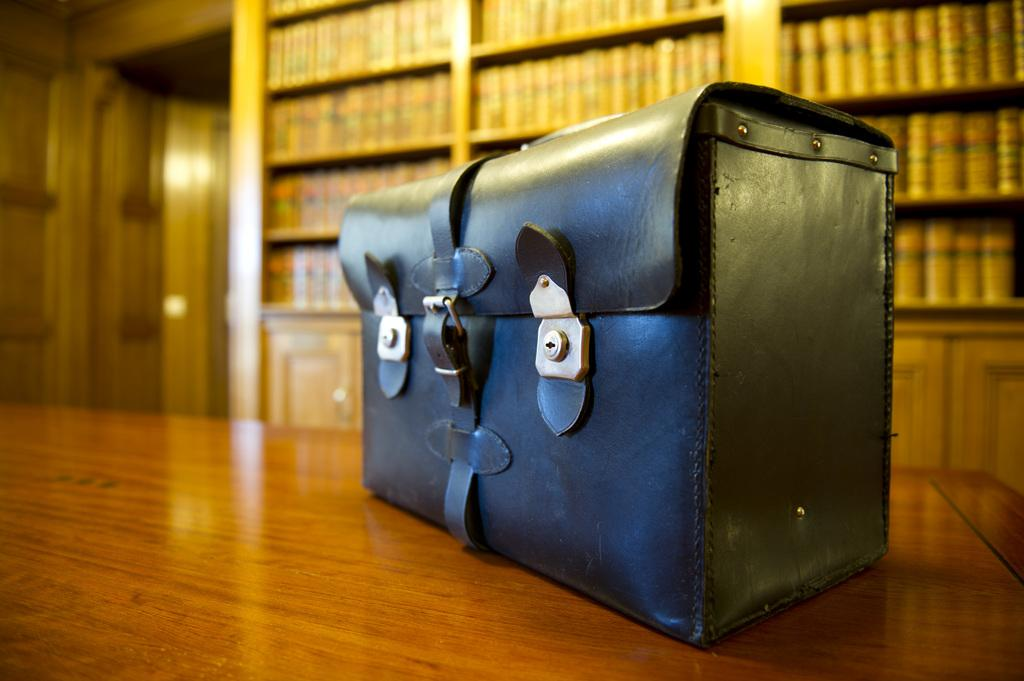What object is placed on the table in the image? There is a black bag on the table. What can be seen in the background of the image? There are books in a rack and a door in the background. How many women are holding spoons in the image? There are no women or spoons present in the image. Is there a squirrel visible in the image? There is no squirrel present in the image. 